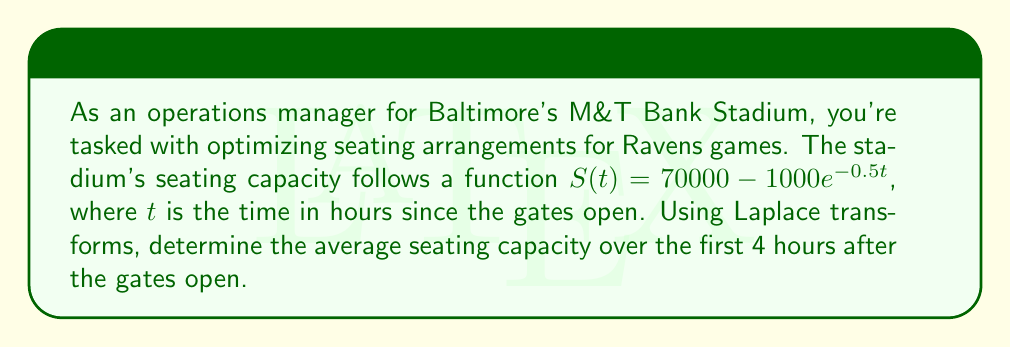Show me your answer to this math problem. To solve this problem, we'll use the following steps:

1) First, we need to find the Laplace transform of $S(t)$:

   $\mathcal{L}\{S(t)\} = \mathcal{L}\{70000 - 1000e^{-0.5t}\}$
   
   $= 70000 \cdot \mathcal{L}\{1\} - 1000 \cdot \mathcal{L}\{e^{-0.5t}\}$
   
   $= \frac{70000}{s} - \frac{1000}{s+0.5}$

2) To find the average over 4 hours, we need to integrate $S(t)$ from 0 to 4 and divide by 4. In the Laplace domain, this is equivalent to:

   $\frac{1}{4} \cdot \frac{1}{s} \cdot \mathcal{L}\{S(t)\} \bigg|_{s=0}$

3) Let's substitute our Laplace transform:

   $\frac{1}{4} \cdot \frac{1}{s} \cdot (\frac{70000}{s} - \frac{1000}{s+0.5}) \bigg|_{s=0}$

4) Simplify:

   $\frac{1}{4} \cdot (\frac{70000}{s^2} - \frac{1000}{s(s+0.5)}) \bigg|_{s=0}$

5) To evaluate this at $s=0$, we need to use L'Hôpital's rule twice:

   $\lim_{s \to 0} \frac{1}{4} \cdot (\frac{70000}{s^2} - \frac{1000}{s(s+0.5)})$
   
   $= \frac{1}{4} \cdot (70000 \cdot 2 - 1000 \cdot 2)$
   
   $= \frac{1}{4} \cdot 138000$
   
   $= 34500$

Therefore, the average seating capacity over the first 4 hours is 34,500.
Answer: 34,500 seats 